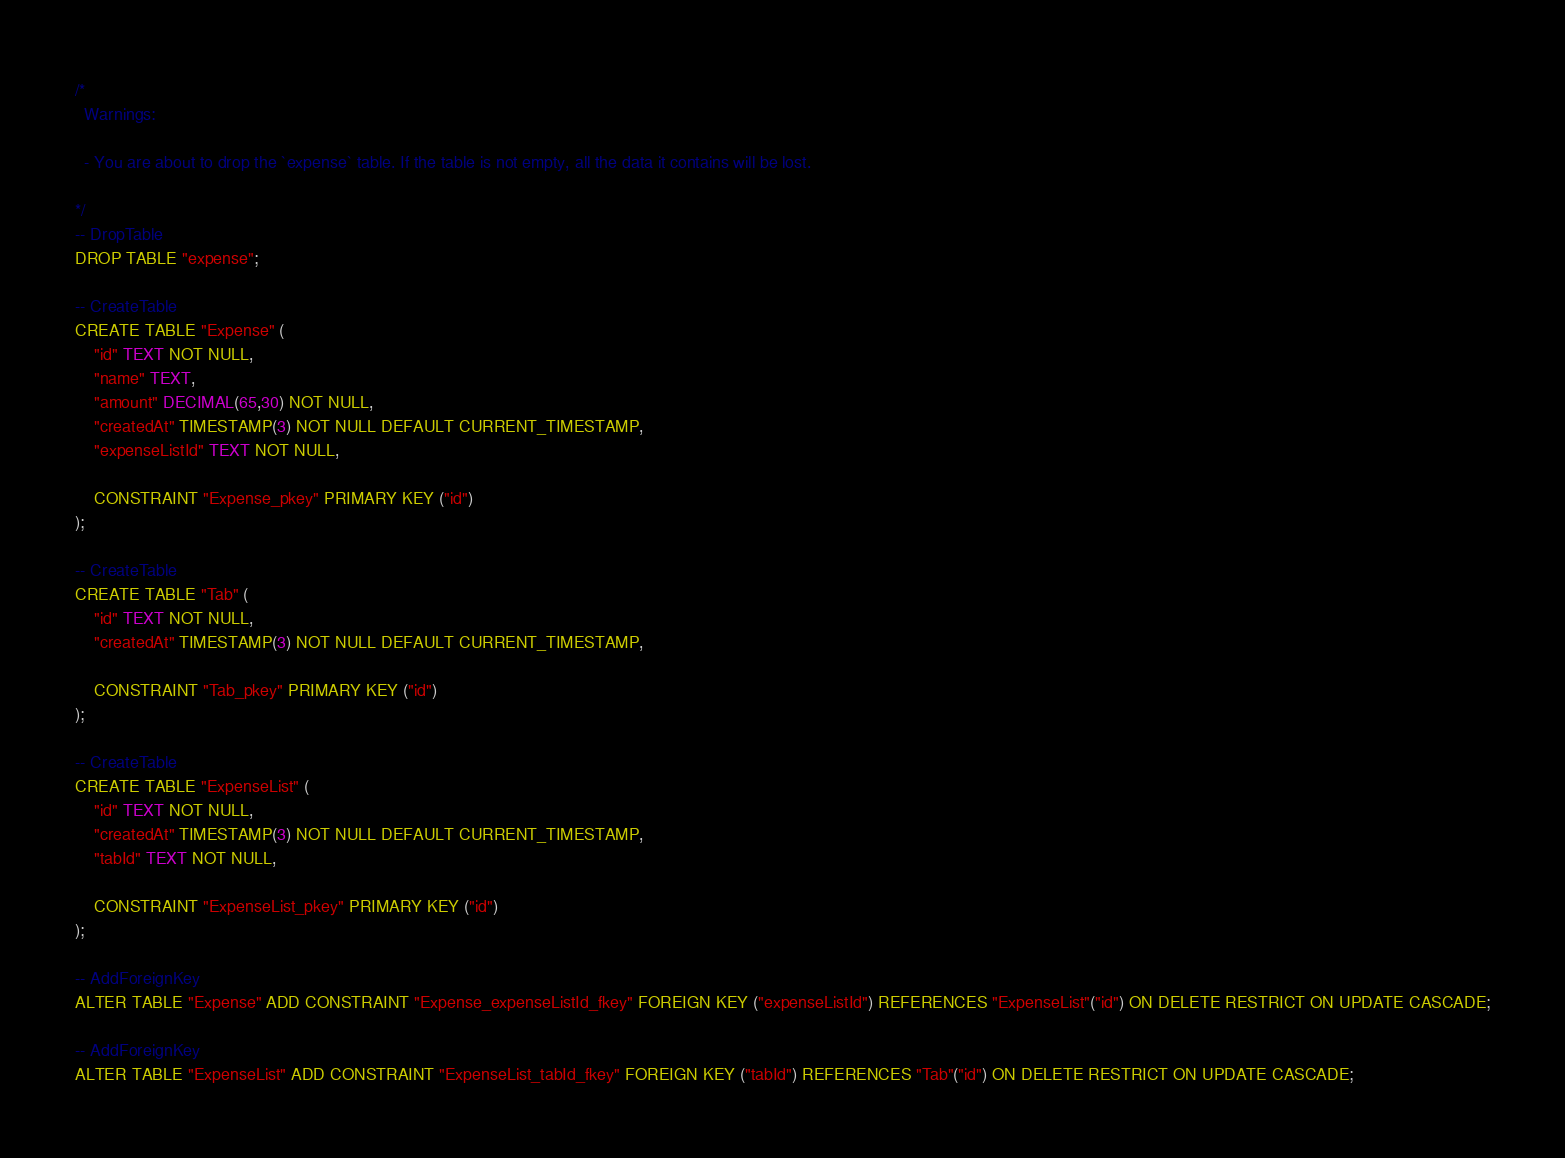Convert code to text. <code><loc_0><loc_0><loc_500><loc_500><_SQL_>/*
  Warnings:

  - You are about to drop the `expense` table. If the table is not empty, all the data it contains will be lost.

*/
-- DropTable
DROP TABLE "expense";

-- CreateTable
CREATE TABLE "Expense" (
    "id" TEXT NOT NULL,
    "name" TEXT,
    "amount" DECIMAL(65,30) NOT NULL,
    "createdAt" TIMESTAMP(3) NOT NULL DEFAULT CURRENT_TIMESTAMP,
    "expenseListId" TEXT NOT NULL,

    CONSTRAINT "Expense_pkey" PRIMARY KEY ("id")
);

-- CreateTable
CREATE TABLE "Tab" (
    "id" TEXT NOT NULL,
    "createdAt" TIMESTAMP(3) NOT NULL DEFAULT CURRENT_TIMESTAMP,

    CONSTRAINT "Tab_pkey" PRIMARY KEY ("id")
);

-- CreateTable
CREATE TABLE "ExpenseList" (
    "id" TEXT NOT NULL,
    "createdAt" TIMESTAMP(3) NOT NULL DEFAULT CURRENT_TIMESTAMP,
    "tabId" TEXT NOT NULL,

    CONSTRAINT "ExpenseList_pkey" PRIMARY KEY ("id")
);

-- AddForeignKey
ALTER TABLE "Expense" ADD CONSTRAINT "Expense_expenseListId_fkey" FOREIGN KEY ("expenseListId") REFERENCES "ExpenseList"("id") ON DELETE RESTRICT ON UPDATE CASCADE;

-- AddForeignKey
ALTER TABLE "ExpenseList" ADD CONSTRAINT "ExpenseList_tabId_fkey" FOREIGN KEY ("tabId") REFERENCES "Tab"("id") ON DELETE RESTRICT ON UPDATE CASCADE;
</code> 